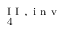Convert formula to latex. <formula><loc_0><loc_0><loc_500><loc_500>_ { 4 } ^ { I I , i n v }</formula> 